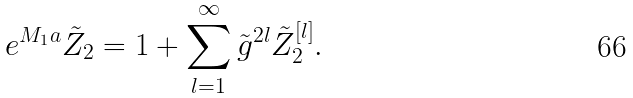<formula> <loc_0><loc_0><loc_500><loc_500>e ^ { M _ { 1 } a } \tilde { Z } _ { 2 } = 1 + \sum _ { l = 1 } ^ { \infty } \tilde { g } ^ { 2 l } \tilde { Z } _ { 2 } ^ { [ l ] } .</formula> 